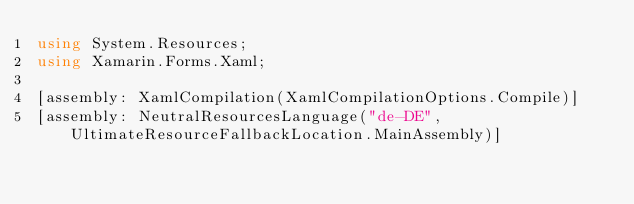<code> <loc_0><loc_0><loc_500><loc_500><_C#_>using System.Resources;
using Xamarin.Forms.Xaml;

[assembly: XamlCompilation(XamlCompilationOptions.Compile)]
[assembly: NeutralResourcesLanguage("de-DE", UltimateResourceFallbackLocation.MainAssembly)]</code> 